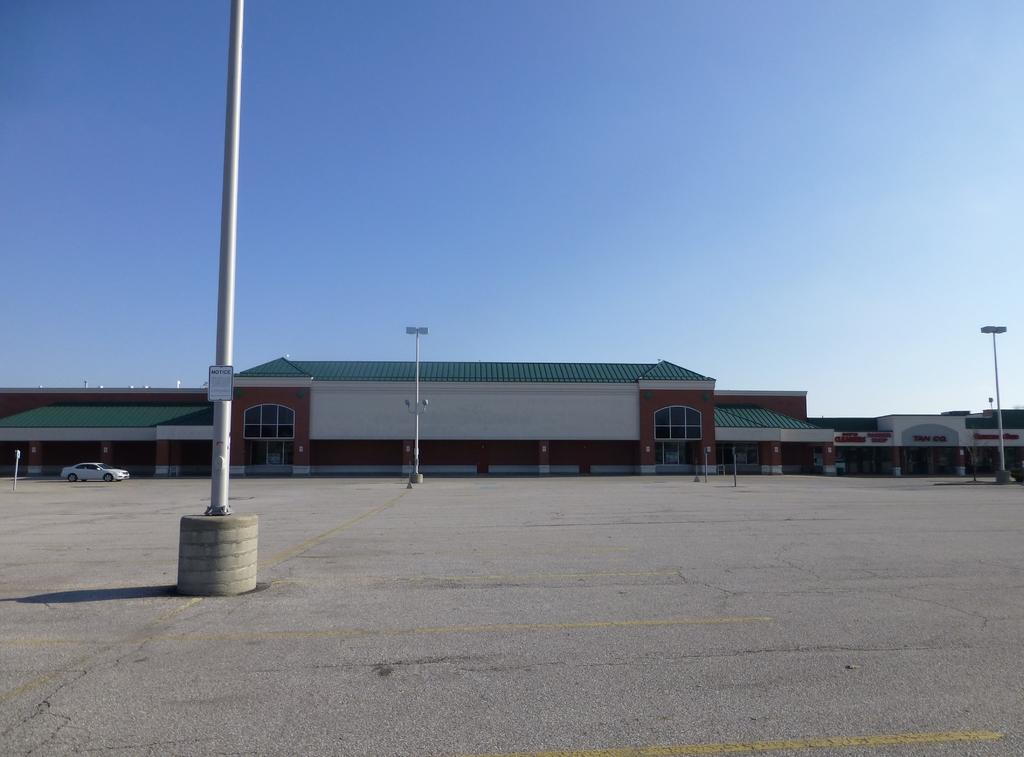What type of structures are located in the center of the image? There are houses in the center of the image. What objects can be seen supporting something in the image? There are poles in the image. What can be seen illuminating the area in the image? There are lights in the image. What type of vehicle is present in the image? There is a car in the image. What is the pathway for people to walk on in the image? There is a walkway at the bottom of the image. What is visible at the top of the image? The sky is visible at the top of the image. Where are the potatoes being stored in the image? There are no potatoes present in the image. What type of drain is visible in the image? There is no drain present in the image. 